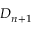Convert formula to latex. <formula><loc_0><loc_0><loc_500><loc_500>D _ { n + 1 }</formula> 